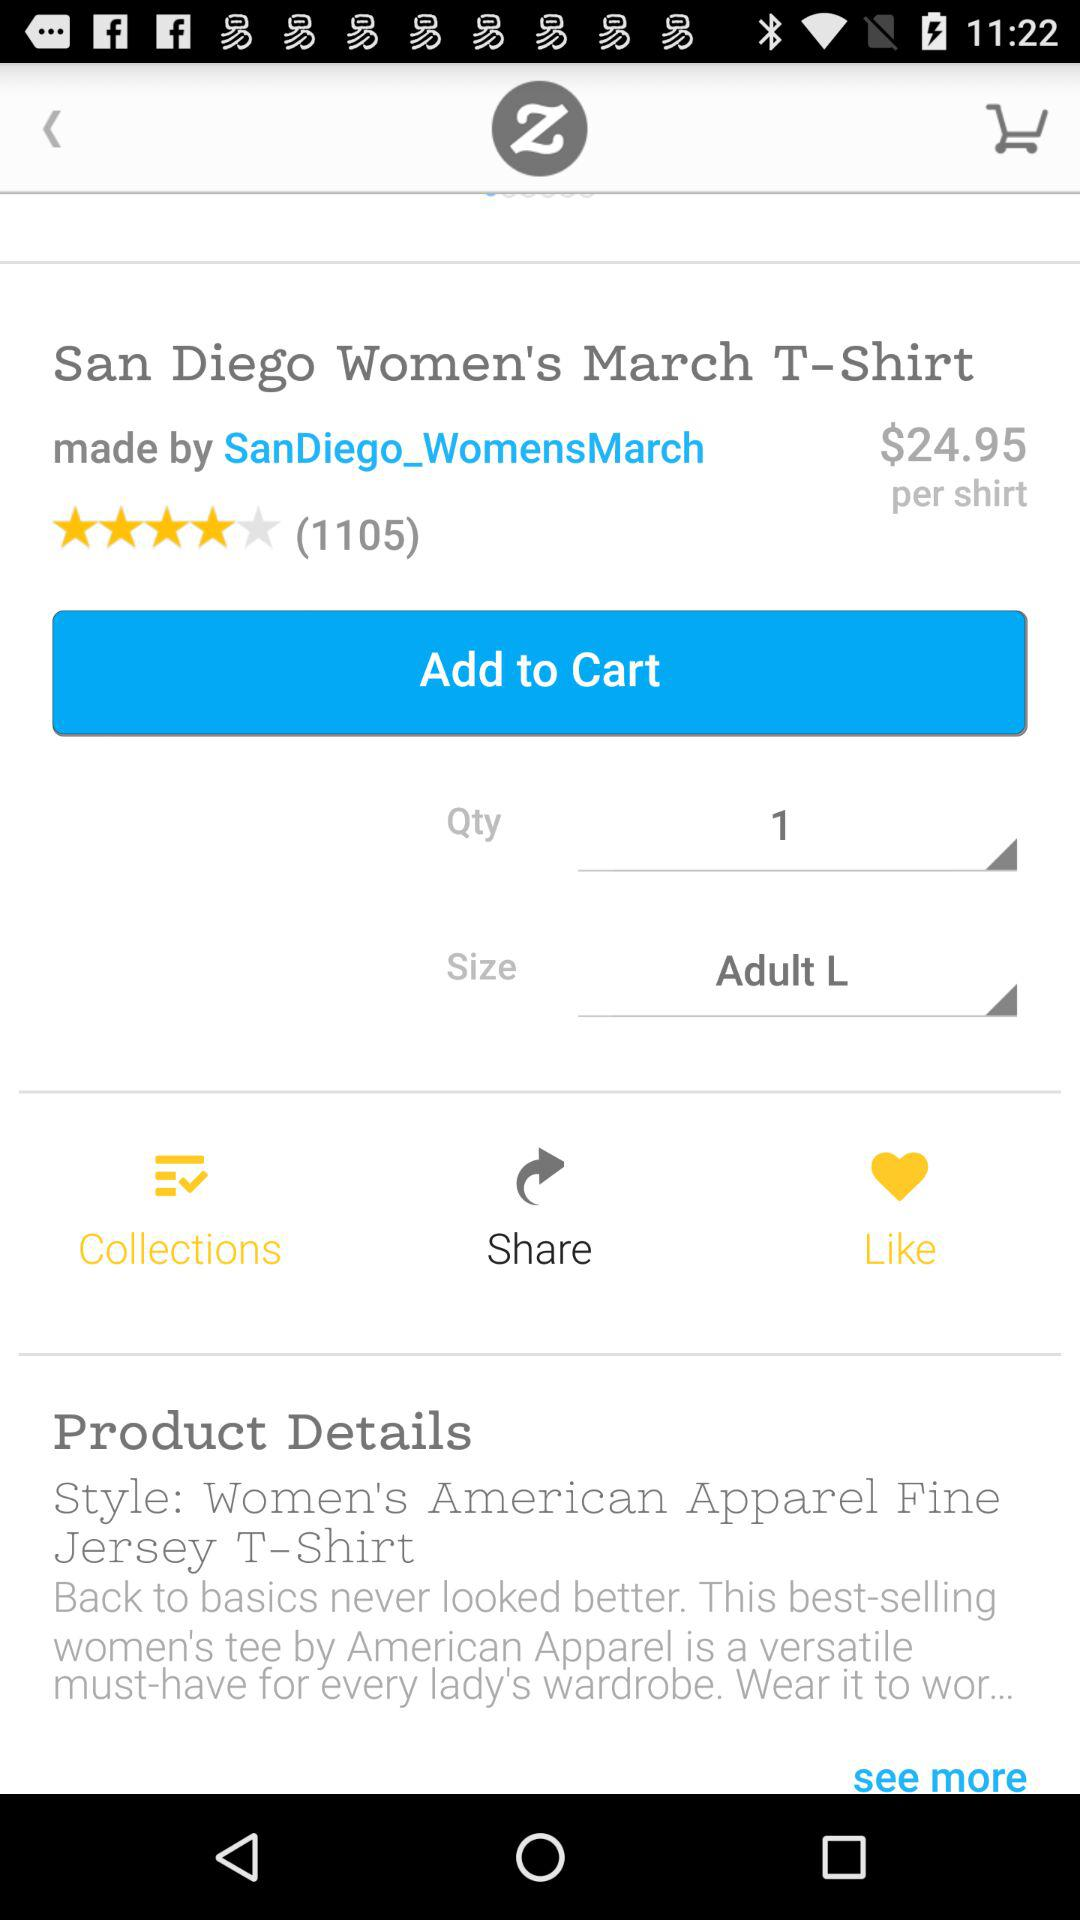What is the star rating of this t-shirt? The star rating of this t-shirt is "4 star". 